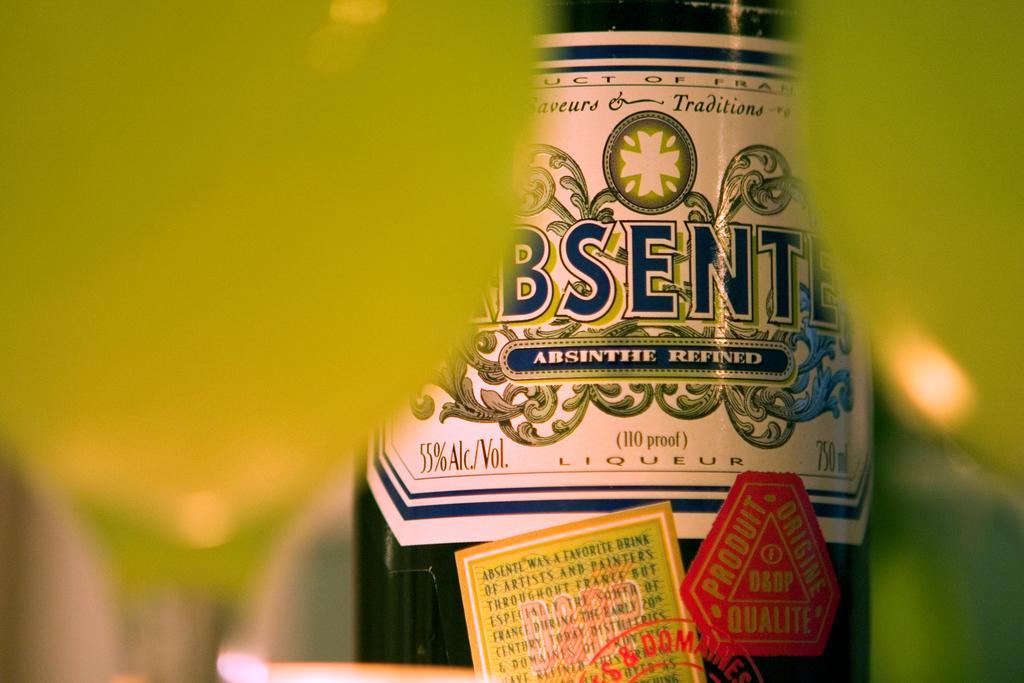<image>
Share a concise interpretation of the image provided. A bottle of absinthe is fifty five percent alcohol. 